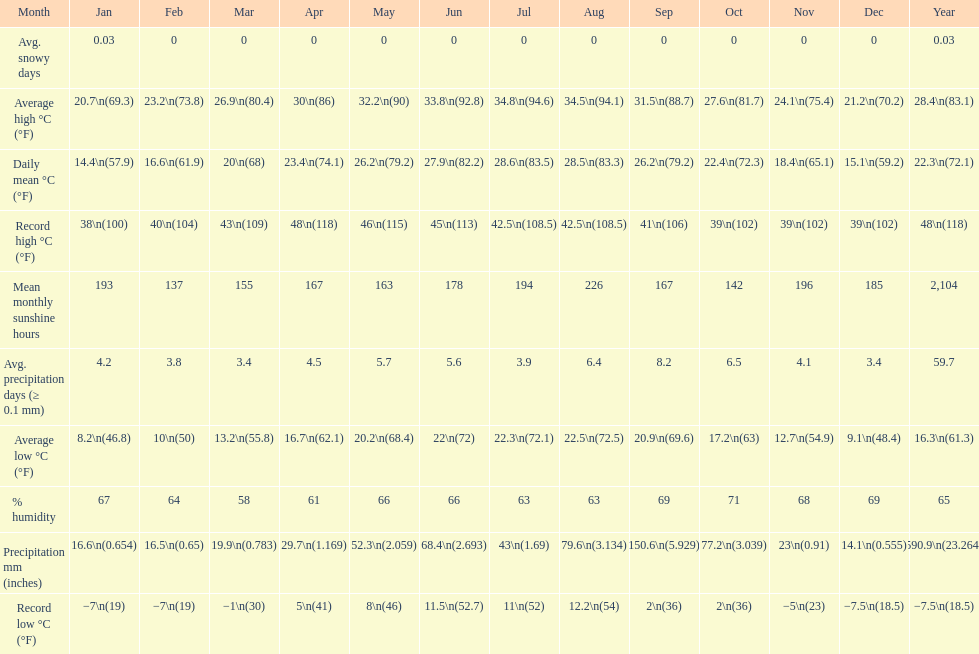Which month had the most sunny days? August. 